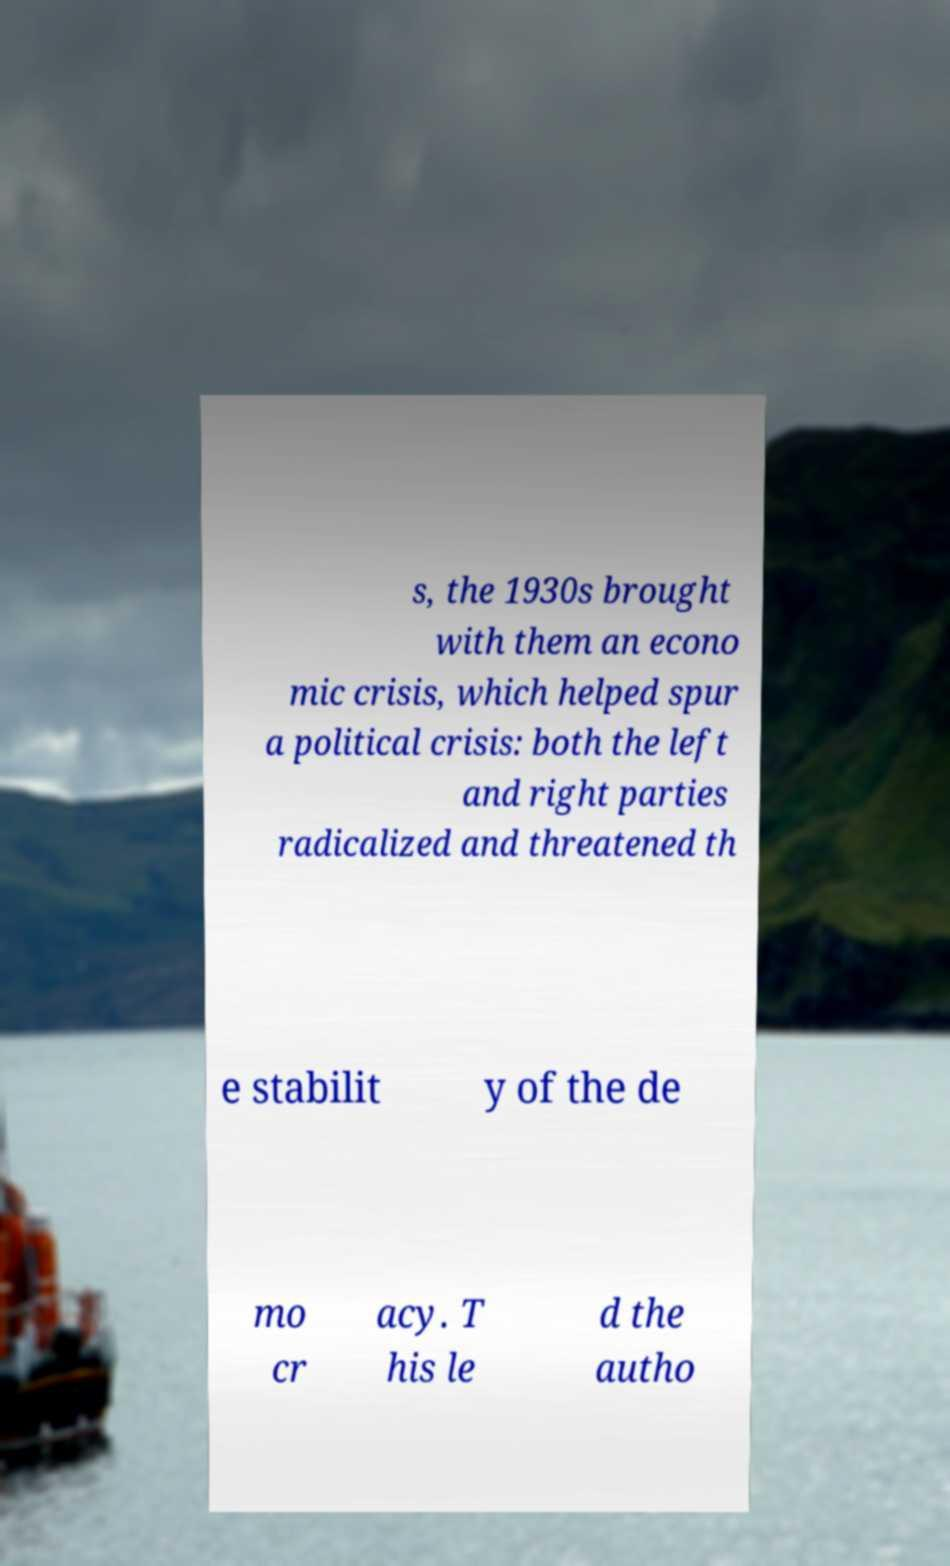For documentation purposes, I need the text within this image transcribed. Could you provide that? s, the 1930s brought with them an econo mic crisis, which helped spur a political crisis: both the left and right parties radicalized and threatened th e stabilit y of the de mo cr acy. T his le d the autho 